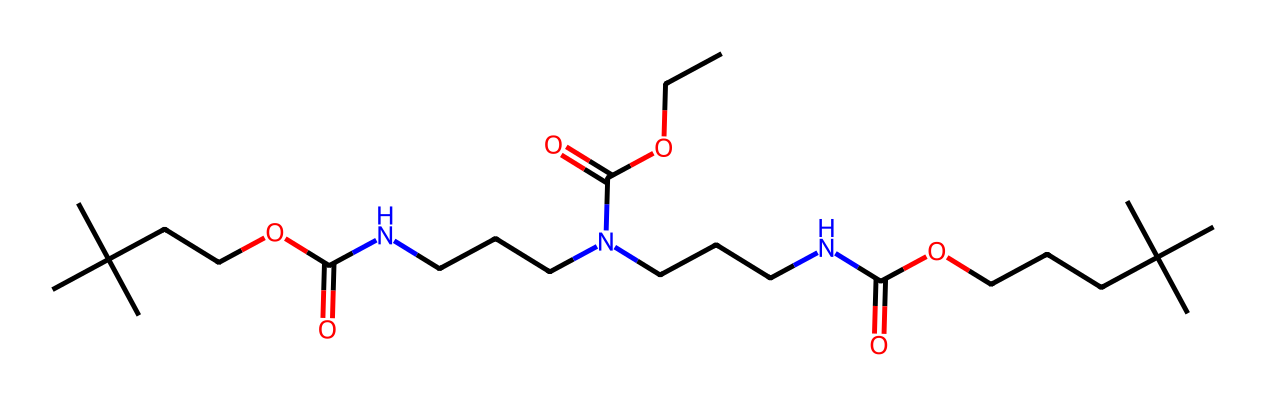How many carbon atoms are present in the structure? By analyzing the SMILES representation, we can count the number of carbon (C) atoms. Each capital letter 'C' indicates a carbon atom. The total counts to 25 carbon atoms when considered in the entire structure.
Answer: 25 What functional groups are present in the structure? The presence of carbonyl (C=O) and amine (N) groups can be identified in the SMILES. The presence of "N" indicates amines, while "C(=O)" indicates the carbonyl functional groups in this structure.
Answer: amine, carbonyl What is the primary use of this chemical structure? This specific structure is designed for its application in flexible foam cushions commonly used in hospital beds and wheelchairs, providing comfort and support.
Answer: foam cushions How many nitrogen atoms are found in the molecule? Similar to counting carbon atoms, we look for the occurrence of nitrogen (N) in the SMILES. There are 5 nitrogen atoms in the entire structure.
Answer: 5 What type of polymer is represented in this structure? This chemical structure represents polyurethane, which is a polymer often utilized in manufacturing foams due to its versatile properties and structure.
Answer: polyurethane What type of interactions are likely responsible for the cushioning properties of this polymer? The polymer exhibits flexible and soft characteristics due to hydrogen bonding between its functional groups, which allows it to deform and recover, contributing to its cushioning properties.
Answer: hydrogen bonding 